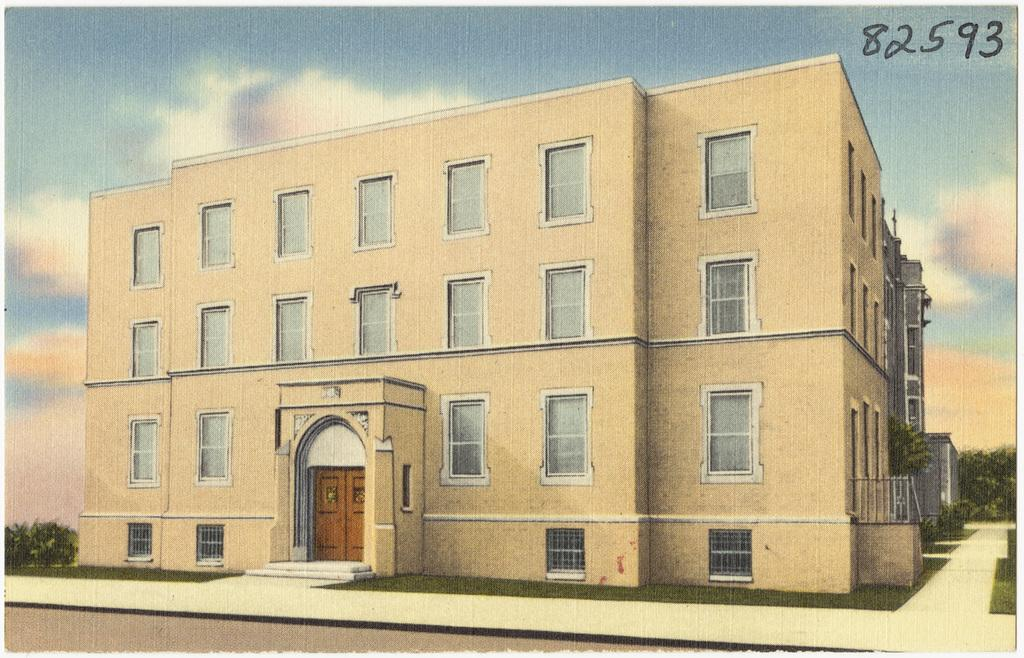What is the main subject of the image? The main subject of the image is a building. What features can be observed on the building? The building has windows and a door. Is there any text visible on the building? Yes, there is text at the top of the building. What can be seen in the background of the image? There are trees and the sky visible in the background of the image. What is the condition of the sky in the image? The sky is visible in the background of the image, and there are clouds present. What is the daily profit of the building in the image? The image does not provide any information about the building's profit, so it cannot be determined. What day is depicted in the image? The image does not indicate a specific day, so it cannot be determined. 